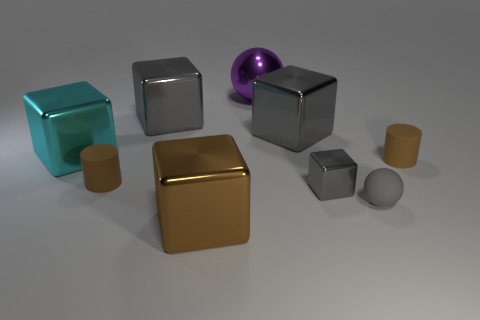There is a tiny metal block; what number of large gray objects are in front of it?
Provide a short and direct response. 0. How many other things are the same size as the brown shiny object?
Offer a terse response. 4. Is the tiny object that is to the left of the large brown cube made of the same material as the ball that is in front of the large cyan thing?
Ensure brevity in your answer.  Yes. There is a metal thing that is the same size as the gray matte thing; what color is it?
Offer a terse response. Gray. Is there anything else of the same color as the small cube?
Offer a very short reply. Yes. What is the size of the cylinder in front of the cylinder to the right of the gray matte ball behind the big brown block?
Offer a very short reply. Small. There is a tiny thing that is on the left side of the small gray rubber object and to the right of the large ball; what is its color?
Your answer should be very brief. Gray. There is a rubber cylinder that is on the right side of the small rubber sphere; what size is it?
Your answer should be very brief. Small. How many large cyan blocks have the same material as the big ball?
Give a very brief answer. 1. There is a rubber object that is the same color as the small metal cube; what shape is it?
Your response must be concise. Sphere. 